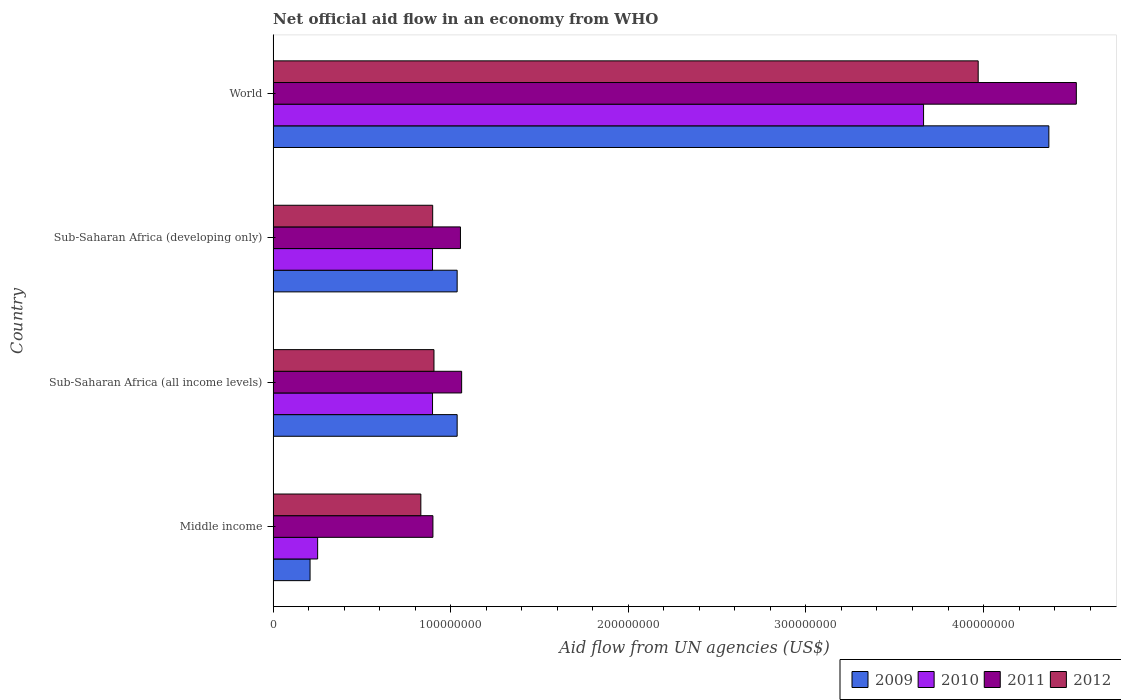How many groups of bars are there?
Your response must be concise. 4. Are the number of bars per tick equal to the number of legend labels?
Your answer should be very brief. Yes. Are the number of bars on each tick of the Y-axis equal?
Ensure brevity in your answer.  Yes. How many bars are there on the 1st tick from the bottom?
Your response must be concise. 4. In how many cases, is the number of bars for a given country not equal to the number of legend labels?
Provide a short and direct response. 0. What is the net official aid flow in 2010 in World?
Give a very brief answer. 3.66e+08. Across all countries, what is the maximum net official aid flow in 2010?
Keep it short and to the point. 3.66e+08. Across all countries, what is the minimum net official aid flow in 2009?
Provide a succinct answer. 2.08e+07. In which country was the net official aid flow in 2011 maximum?
Offer a very short reply. World. In which country was the net official aid flow in 2009 minimum?
Offer a terse response. Middle income. What is the total net official aid flow in 2012 in the graph?
Your answer should be very brief. 6.61e+08. What is the difference between the net official aid flow in 2011 in Middle income and that in World?
Your answer should be compact. -3.62e+08. What is the average net official aid flow in 2010 per country?
Your answer should be very brief. 1.43e+08. What is the difference between the net official aid flow in 2012 and net official aid flow in 2011 in Middle income?
Your response must be concise. -6.80e+06. What is the ratio of the net official aid flow in 2012 in Sub-Saharan Africa (all income levels) to that in World?
Keep it short and to the point. 0.23. Is the difference between the net official aid flow in 2012 in Middle income and World greater than the difference between the net official aid flow in 2011 in Middle income and World?
Provide a succinct answer. Yes. What is the difference between the highest and the second highest net official aid flow in 2010?
Keep it short and to the point. 2.76e+08. What is the difference between the highest and the lowest net official aid flow in 2009?
Your answer should be compact. 4.16e+08. In how many countries, is the net official aid flow in 2011 greater than the average net official aid flow in 2011 taken over all countries?
Your response must be concise. 1. Is it the case that in every country, the sum of the net official aid flow in 2010 and net official aid flow in 2011 is greater than the sum of net official aid flow in 2012 and net official aid flow in 2009?
Your answer should be compact. No. Is it the case that in every country, the sum of the net official aid flow in 2011 and net official aid flow in 2010 is greater than the net official aid flow in 2012?
Your answer should be very brief. Yes. What is the difference between two consecutive major ticks on the X-axis?
Your answer should be compact. 1.00e+08. Are the values on the major ticks of X-axis written in scientific E-notation?
Ensure brevity in your answer.  No. Does the graph contain grids?
Make the answer very short. No. Where does the legend appear in the graph?
Keep it short and to the point. Bottom right. How are the legend labels stacked?
Keep it short and to the point. Horizontal. What is the title of the graph?
Keep it short and to the point. Net official aid flow in an economy from WHO. Does "1994" appear as one of the legend labels in the graph?
Your answer should be very brief. No. What is the label or title of the X-axis?
Provide a short and direct response. Aid flow from UN agencies (US$). What is the Aid flow from UN agencies (US$) in 2009 in Middle income?
Your response must be concise. 2.08e+07. What is the Aid flow from UN agencies (US$) in 2010 in Middle income?
Keep it short and to the point. 2.51e+07. What is the Aid flow from UN agencies (US$) in 2011 in Middle income?
Give a very brief answer. 9.00e+07. What is the Aid flow from UN agencies (US$) of 2012 in Middle income?
Provide a short and direct response. 8.32e+07. What is the Aid flow from UN agencies (US$) in 2009 in Sub-Saharan Africa (all income levels)?
Ensure brevity in your answer.  1.04e+08. What is the Aid flow from UN agencies (US$) in 2010 in Sub-Saharan Africa (all income levels)?
Give a very brief answer. 8.98e+07. What is the Aid flow from UN agencies (US$) of 2011 in Sub-Saharan Africa (all income levels)?
Your answer should be compact. 1.06e+08. What is the Aid flow from UN agencies (US$) of 2012 in Sub-Saharan Africa (all income levels)?
Provide a succinct answer. 9.06e+07. What is the Aid flow from UN agencies (US$) in 2009 in Sub-Saharan Africa (developing only)?
Ensure brevity in your answer.  1.04e+08. What is the Aid flow from UN agencies (US$) of 2010 in Sub-Saharan Africa (developing only)?
Offer a terse response. 8.98e+07. What is the Aid flow from UN agencies (US$) of 2011 in Sub-Saharan Africa (developing only)?
Ensure brevity in your answer.  1.05e+08. What is the Aid flow from UN agencies (US$) of 2012 in Sub-Saharan Africa (developing only)?
Provide a succinct answer. 8.98e+07. What is the Aid flow from UN agencies (US$) in 2009 in World?
Ensure brevity in your answer.  4.37e+08. What is the Aid flow from UN agencies (US$) of 2010 in World?
Your response must be concise. 3.66e+08. What is the Aid flow from UN agencies (US$) in 2011 in World?
Make the answer very short. 4.52e+08. What is the Aid flow from UN agencies (US$) of 2012 in World?
Keep it short and to the point. 3.97e+08. Across all countries, what is the maximum Aid flow from UN agencies (US$) of 2009?
Your answer should be compact. 4.37e+08. Across all countries, what is the maximum Aid flow from UN agencies (US$) of 2010?
Offer a very short reply. 3.66e+08. Across all countries, what is the maximum Aid flow from UN agencies (US$) in 2011?
Ensure brevity in your answer.  4.52e+08. Across all countries, what is the maximum Aid flow from UN agencies (US$) in 2012?
Provide a succinct answer. 3.97e+08. Across all countries, what is the minimum Aid flow from UN agencies (US$) in 2009?
Offer a terse response. 2.08e+07. Across all countries, what is the minimum Aid flow from UN agencies (US$) in 2010?
Make the answer very short. 2.51e+07. Across all countries, what is the minimum Aid flow from UN agencies (US$) in 2011?
Offer a very short reply. 9.00e+07. Across all countries, what is the minimum Aid flow from UN agencies (US$) in 2012?
Provide a short and direct response. 8.32e+07. What is the total Aid flow from UN agencies (US$) of 2009 in the graph?
Ensure brevity in your answer.  6.65e+08. What is the total Aid flow from UN agencies (US$) of 2010 in the graph?
Ensure brevity in your answer.  5.71e+08. What is the total Aid flow from UN agencies (US$) of 2011 in the graph?
Your response must be concise. 7.54e+08. What is the total Aid flow from UN agencies (US$) of 2012 in the graph?
Your answer should be compact. 6.61e+08. What is the difference between the Aid flow from UN agencies (US$) of 2009 in Middle income and that in Sub-Saharan Africa (all income levels)?
Give a very brief answer. -8.28e+07. What is the difference between the Aid flow from UN agencies (US$) in 2010 in Middle income and that in Sub-Saharan Africa (all income levels)?
Give a very brief answer. -6.47e+07. What is the difference between the Aid flow from UN agencies (US$) in 2011 in Middle income and that in Sub-Saharan Africa (all income levels)?
Your answer should be compact. -1.62e+07. What is the difference between the Aid flow from UN agencies (US$) of 2012 in Middle income and that in Sub-Saharan Africa (all income levels)?
Offer a very short reply. -7.39e+06. What is the difference between the Aid flow from UN agencies (US$) of 2009 in Middle income and that in Sub-Saharan Africa (developing only)?
Your response must be concise. -8.28e+07. What is the difference between the Aid flow from UN agencies (US$) in 2010 in Middle income and that in Sub-Saharan Africa (developing only)?
Provide a short and direct response. -6.47e+07. What is the difference between the Aid flow from UN agencies (US$) of 2011 in Middle income and that in Sub-Saharan Africa (developing only)?
Provide a succinct answer. -1.55e+07. What is the difference between the Aid flow from UN agencies (US$) in 2012 in Middle income and that in Sub-Saharan Africa (developing only)?
Offer a very short reply. -6.67e+06. What is the difference between the Aid flow from UN agencies (US$) of 2009 in Middle income and that in World?
Make the answer very short. -4.16e+08. What is the difference between the Aid flow from UN agencies (US$) of 2010 in Middle income and that in World?
Ensure brevity in your answer.  -3.41e+08. What is the difference between the Aid flow from UN agencies (US$) in 2011 in Middle income and that in World?
Provide a succinct answer. -3.62e+08. What is the difference between the Aid flow from UN agencies (US$) in 2012 in Middle income and that in World?
Provide a succinct answer. -3.14e+08. What is the difference between the Aid flow from UN agencies (US$) in 2009 in Sub-Saharan Africa (all income levels) and that in Sub-Saharan Africa (developing only)?
Your answer should be very brief. 0. What is the difference between the Aid flow from UN agencies (US$) in 2010 in Sub-Saharan Africa (all income levels) and that in Sub-Saharan Africa (developing only)?
Make the answer very short. 0. What is the difference between the Aid flow from UN agencies (US$) in 2011 in Sub-Saharan Africa (all income levels) and that in Sub-Saharan Africa (developing only)?
Your answer should be compact. 6.70e+05. What is the difference between the Aid flow from UN agencies (US$) of 2012 in Sub-Saharan Africa (all income levels) and that in Sub-Saharan Africa (developing only)?
Provide a short and direct response. 7.20e+05. What is the difference between the Aid flow from UN agencies (US$) in 2009 in Sub-Saharan Africa (all income levels) and that in World?
Make the answer very short. -3.33e+08. What is the difference between the Aid flow from UN agencies (US$) in 2010 in Sub-Saharan Africa (all income levels) and that in World?
Provide a succinct answer. -2.76e+08. What is the difference between the Aid flow from UN agencies (US$) in 2011 in Sub-Saharan Africa (all income levels) and that in World?
Make the answer very short. -3.46e+08. What is the difference between the Aid flow from UN agencies (US$) of 2012 in Sub-Saharan Africa (all income levels) and that in World?
Give a very brief answer. -3.06e+08. What is the difference between the Aid flow from UN agencies (US$) in 2009 in Sub-Saharan Africa (developing only) and that in World?
Offer a terse response. -3.33e+08. What is the difference between the Aid flow from UN agencies (US$) of 2010 in Sub-Saharan Africa (developing only) and that in World?
Offer a terse response. -2.76e+08. What is the difference between the Aid flow from UN agencies (US$) in 2011 in Sub-Saharan Africa (developing only) and that in World?
Ensure brevity in your answer.  -3.47e+08. What is the difference between the Aid flow from UN agencies (US$) of 2012 in Sub-Saharan Africa (developing only) and that in World?
Offer a very short reply. -3.07e+08. What is the difference between the Aid flow from UN agencies (US$) of 2009 in Middle income and the Aid flow from UN agencies (US$) of 2010 in Sub-Saharan Africa (all income levels)?
Keep it short and to the point. -6.90e+07. What is the difference between the Aid flow from UN agencies (US$) of 2009 in Middle income and the Aid flow from UN agencies (US$) of 2011 in Sub-Saharan Africa (all income levels)?
Offer a very short reply. -8.54e+07. What is the difference between the Aid flow from UN agencies (US$) in 2009 in Middle income and the Aid flow from UN agencies (US$) in 2012 in Sub-Saharan Africa (all income levels)?
Offer a terse response. -6.98e+07. What is the difference between the Aid flow from UN agencies (US$) of 2010 in Middle income and the Aid flow from UN agencies (US$) of 2011 in Sub-Saharan Africa (all income levels)?
Keep it short and to the point. -8.11e+07. What is the difference between the Aid flow from UN agencies (US$) of 2010 in Middle income and the Aid flow from UN agencies (US$) of 2012 in Sub-Saharan Africa (all income levels)?
Keep it short and to the point. -6.55e+07. What is the difference between the Aid flow from UN agencies (US$) of 2011 in Middle income and the Aid flow from UN agencies (US$) of 2012 in Sub-Saharan Africa (all income levels)?
Ensure brevity in your answer.  -5.90e+05. What is the difference between the Aid flow from UN agencies (US$) in 2009 in Middle income and the Aid flow from UN agencies (US$) in 2010 in Sub-Saharan Africa (developing only)?
Ensure brevity in your answer.  -6.90e+07. What is the difference between the Aid flow from UN agencies (US$) of 2009 in Middle income and the Aid flow from UN agencies (US$) of 2011 in Sub-Saharan Africa (developing only)?
Give a very brief answer. -8.47e+07. What is the difference between the Aid flow from UN agencies (US$) in 2009 in Middle income and the Aid flow from UN agencies (US$) in 2012 in Sub-Saharan Africa (developing only)?
Ensure brevity in your answer.  -6.90e+07. What is the difference between the Aid flow from UN agencies (US$) of 2010 in Middle income and the Aid flow from UN agencies (US$) of 2011 in Sub-Saharan Africa (developing only)?
Ensure brevity in your answer.  -8.04e+07. What is the difference between the Aid flow from UN agencies (US$) of 2010 in Middle income and the Aid flow from UN agencies (US$) of 2012 in Sub-Saharan Africa (developing only)?
Keep it short and to the point. -6.48e+07. What is the difference between the Aid flow from UN agencies (US$) of 2009 in Middle income and the Aid flow from UN agencies (US$) of 2010 in World?
Your answer should be very brief. -3.45e+08. What is the difference between the Aid flow from UN agencies (US$) in 2009 in Middle income and the Aid flow from UN agencies (US$) in 2011 in World?
Offer a terse response. -4.31e+08. What is the difference between the Aid flow from UN agencies (US$) in 2009 in Middle income and the Aid flow from UN agencies (US$) in 2012 in World?
Ensure brevity in your answer.  -3.76e+08. What is the difference between the Aid flow from UN agencies (US$) of 2010 in Middle income and the Aid flow from UN agencies (US$) of 2011 in World?
Your response must be concise. -4.27e+08. What is the difference between the Aid flow from UN agencies (US$) in 2010 in Middle income and the Aid flow from UN agencies (US$) in 2012 in World?
Your answer should be very brief. -3.72e+08. What is the difference between the Aid flow from UN agencies (US$) of 2011 in Middle income and the Aid flow from UN agencies (US$) of 2012 in World?
Make the answer very short. -3.07e+08. What is the difference between the Aid flow from UN agencies (US$) of 2009 in Sub-Saharan Africa (all income levels) and the Aid flow from UN agencies (US$) of 2010 in Sub-Saharan Africa (developing only)?
Provide a succinct answer. 1.39e+07. What is the difference between the Aid flow from UN agencies (US$) of 2009 in Sub-Saharan Africa (all income levels) and the Aid flow from UN agencies (US$) of 2011 in Sub-Saharan Africa (developing only)?
Your response must be concise. -1.86e+06. What is the difference between the Aid flow from UN agencies (US$) of 2009 in Sub-Saharan Africa (all income levels) and the Aid flow from UN agencies (US$) of 2012 in Sub-Saharan Africa (developing only)?
Give a very brief answer. 1.38e+07. What is the difference between the Aid flow from UN agencies (US$) of 2010 in Sub-Saharan Africa (all income levels) and the Aid flow from UN agencies (US$) of 2011 in Sub-Saharan Africa (developing only)?
Your answer should be compact. -1.57e+07. What is the difference between the Aid flow from UN agencies (US$) of 2010 in Sub-Saharan Africa (all income levels) and the Aid flow from UN agencies (US$) of 2012 in Sub-Saharan Africa (developing only)?
Provide a succinct answer. -9.00e+04. What is the difference between the Aid flow from UN agencies (US$) in 2011 in Sub-Saharan Africa (all income levels) and the Aid flow from UN agencies (US$) in 2012 in Sub-Saharan Africa (developing only)?
Offer a terse response. 1.63e+07. What is the difference between the Aid flow from UN agencies (US$) in 2009 in Sub-Saharan Africa (all income levels) and the Aid flow from UN agencies (US$) in 2010 in World?
Offer a terse response. -2.63e+08. What is the difference between the Aid flow from UN agencies (US$) of 2009 in Sub-Saharan Africa (all income levels) and the Aid flow from UN agencies (US$) of 2011 in World?
Make the answer very short. -3.49e+08. What is the difference between the Aid flow from UN agencies (US$) of 2009 in Sub-Saharan Africa (all income levels) and the Aid flow from UN agencies (US$) of 2012 in World?
Offer a very short reply. -2.93e+08. What is the difference between the Aid flow from UN agencies (US$) of 2010 in Sub-Saharan Africa (all income levels) and the Aid flow from UN agencies (US$) of 2011 in World?
Keep it short and to the point. -3.62e+08. What is the difference between the Aid flow from UN agencies (US$) in 2010 in Sub-Saharan Africa (all income levels) and the Aid flow from UN agencies (US$) in 2012 in World?
Provide a succinct answer. -3.07e+08. What is the difference between the Aid flow from UN agencies (US$) in 2011 in Sub-Saharan Africa (all income levels) and the Aid flow from UN agencies (US$) in 2012 in World?
Give a very brief answer. -2.91e+08. What is the difference between the Aid flow from UN agencies (US$) of 2009 in Sub-Saharan Africa (developing only) and the Aid flow from UN agencies (US$) of 2010 in World?
Make the answer very short. -2.63e+08. What is the difference between the Aid flow from UN agencies (US$) of 2009 in Sub-Saharan Africa (developing only) and the Aid flow from UN agencies (US$) of 2011 in World?
Your answer should be compact. -3.49e+08. What is the difference between the Aid flow from UN agencies (US$) in 2009 in Sub-Saharan Africa (developing only) and the Aid flow from UN agencies (US$) in 2012 in World?
Give a very brief answer. -2.93e+08. What is the difference between the Aid flow from UN agencies (US$) of 2010 in Sub-Saharan Africa (developing only) and the Aid flow from UN agencies (US$) of 2011 in World?
Give a very brief answer. -3.62e+08. What is the difference between the Aid flow from UN agencies (US$) of 2010 in Sub-Saharan Africa (developing only) and the Aid flow from UN agencies (US$) of 2012 in World?
Offer a terse response. -3.07e+08. What is the difference between the Aid flow from UN agencies (US$) of 2011 in Sub-Saharan Africa (developing only) and the Aid flow from UN agencies (US$) of 2012 in World?
Provide a succinct answer. -2.92e+08. What is the average Aid flow from UN agencies (US$) of 2009 per country?
Keep it short and to the point. 1.66e+08. What is the average Aid flow from UN agencies (US$) of 2010 per country?
Your answer should be compact. 1.43e+08. What is the average Aid flow from UN agencies (US$) in 2011 per country?
Offer a terse response. 1.88e+08. What is the average Aid flow from UN agencies (US$) in 2012 per country?
Give a very brief answer. 1.65e+08. What is the difference between the Aid flow from UN agencies (US$) in 2009 and Aid flow from UN agencies (US$) in 2010 in Middle income?
Provide a short and direct response. -4.27e+06. What is the difference between the Aid flow from UN agencies (US$) in 2009 and Aid flow from UN agencies (US$) in 2011 in Middle income?
Provide a short and direct response. -6.92e+07. What is the difference between the Aid flow from UN agencies (US$) in 2009 and Aid flow from UN agencies (US$) in 2012 in Middle income?
Give a very brief answer. -6.24e+07. What is the difference between the Aid flow from UN agencies (US$) in 2010 and Aid flow from UN agencies (US$) in 2011 in Middle income?
Provide a succinct answer. -6.49e+07. What is the difference between the Aid flow from UN agencies (US$) in 2010 and Aid flow from UN agencies (US$) in 2012 in Middle income?
Your answer should be very brief. -5.81e+07. What is the difference between the Aid flow from UN agencies (US$) in 2011 and Aid flow from UN agencies (US$) in 2012 in Middle income?
Make the answer very short. 6.80e+06. What is the difference between the Aid flow from UN agencies (US$) of 2009 and Aid flow from UN agencies (US$) of 2010 in Sub-Saharan Africa (all income levels)?
Ensure brevity in your answer.  1.39e+07. What is the difference between the Aid flow from UN agencies (US$) in 2009 and Aid flow from UN agencies (US$) in 2011 in Sub-Saharan Africa (all income levels)?
Provide a succinct answer. -2.53e+06. What is the difference between the Aid flow from UN agencies (US$) in 2009 and Aid flow from UN agencies (US$) in 2012 in Sub-Saharan Africa (all income levels)?
Provide a short and direct response. 1.30e+07. What is the difference between the Aid flow from UN agencies (US$) of 2010 and Aid flow from UN agencies (US$) of 2011 in Sub-Saharan Africa (all income levels)?
Provide a succinct answer. -1.64e+07. What is the difference between the Aid flow from UN agencies (US$) in 2010 and Aid flow from UN agencies (US$) in 2012 in Sub-Saharan Africa (all income levels)?
Provide a succinct answer. -8.10e+05. What is the difference between the Aid flow from UN agencies (US$) in 2011 and Aid flow from UN agencies (US$) in 2012 in Sub-Saharan Africa (all income levels)?
Provide a short and direct response. 1.56e+07. What is the difference between the Aid flow from UN agencies (US$) of 2009 and Aid flow from UN agencies (US$) of 2010 in Sub-Saharan Africa (developing only)?
Your answer should be compact. 1.39e+07. What is the difference between the Aid flow from UN agencies (US$) of 2009 and Aid flow from UN agencies (US$) of 2011 in Sub-Saharan Africa (developing only)?
Offer a terse response. -1.86e+06. What is the difference between the Aid flow from UN agencies (US$) of 2009 and Aid flow from UN agencies (US$) of 2012 in Sub-Saharan Africa (developing only)?
Provide a short and direct response. 1.38e+07. What is the difference between the Aid flow from UN agencies (US$) of 2010 and Aid flow from UN agencies (US$) of 2011 in Sub-Saharan Africa (developing only)?
Provide a short and direct response. -1.57e+07. What is the difference between the Aid flow from UN agencies (US$) in 2010 and Aid flow from UN agencies (US$) in 2012 in Sub-Saharan Africa (developing only)?
Offer a terse response. -9.00e+04. What is the difference between the Aid flow from UN agencies (US$) in 2011 and Aid flow from UN agencies (US$) in 2012 in Sub-Saharan Africa (developing only)?
Offer a very short reply. 1.56e+07. What is the difference between the Aid flow from UN agencies (US$) of 2009 and Aid flow from UN agencies (US$) of 2010 in World?
Offer a very short reply. 7.06e+07. What is the difference between the Aid flow from UN agencies (US$) in 2009 and Aid flow from UN agencies (US$) in 2011 in World?
Make the answer very short. -1.55e+07. What is the difference between the Aid flow from UN agencies (US$) of 2009 and Aid flow from UN agencies (US$) of 2012 in World?
Provide a succinct answer. 3.98e+07. What is the difference between the Aid flow from UN agencies (US$) in 2010 and Aid flow from UN agencies (US$) in 2011 in World?
Provide a succinct answer. -8.60e+07. What is the difference between the Aid flow from UN agencies (US$) in 2010 and Aid flow from UN agencies (US$) in 2012 in World?
Your answer should be very brief. -3.08e+07. What is the difference between the Aid flow from UN agencies (US$) in 2011 and Aid flow from UN agencies (US$) in 2012 in World?
Keep it short and to the point. 5.53e+07. What is the ratio of the Aid flow from UN agencies (US$) of 2009 in Middle income to that in Sub-Saharan Africa (all income levels)?
Offer a very short reply. 0.2. What is the ratio of the Aid flow from UN agencies (US$) in 2010 in Middle income to that in Sub-Saharan Africa (all income levels)?
Offer a very short reply. 0.28. What is the ratio of the Aid flow from UN agencies (US$) in 2011 in Middle income to that in Sub-Saharan Africa (all income levels)?
Your response must be concise. 0.85. What is the ratio of the Aid flow from UN agencies (US$) in 2012 in Middle income to that in Sub-Saharan Africa (all income levels)?
Give a very brief answer. 0.92. What is the ratio of the Aid flow from UN agencies (US$) of 2009 in Middle income to that in Sub-Saharan Africa (developing only)?
Make the answer very short. 0.2. What is the ratio of the Aid flow from UN agencies (US$) in 2010 in Middle income to that in Sub-Saharan Africa (developing only)?
Keep it short and to the point. 0.28. What is the ratio of the Aid flow from UN agencies (US$) in 2011 in Middle income to that in Sub-Saharan Africa (developing only)?
Keep it short and to the point. 0.85. What is the ratio of the Aid flow from UN agencies (US$) in 2012 in Middle income to that in Sub-Saharan Africa (developing only)?
Provide a succinct answer. 0.93. What is the ratio of the Aid flow from UN agencies (US$) in 2009 in Middle income to that in World?
Your response must be concise. 0.05. What is the ratio of the Aid flow from UN agencies (US$) of 2010 in Middle income to that in World?
Provide a short and direct response. 0.07. What is the ratio of the Aid flow from UN agencies (US$) of 2011 in Middle income to that in World?
Make the answer very short. 0.2. What is the ratio of the Aid flow from UN agencies (US$) of 2012 in Middle income to that in World?
Your answer should be very brief. 0.21. What is the ratio of the Aid flow from UN agencies (US$) of 2011 in Sub-Saharan Africa (all income levels) to that in Sub-Saharan Africa (developing only)?
Your answer should be very brief. 1.01. What is the ratio of the Aid flow from UN agencies (US$) in 2009 in Sub-Saharan Africa (all income levels) to that in World?
Make the answer very short. 0.24. What is the ratio of the Aid flow from UN agencies (US$) of 2010 in Sub-Saharan Africa (all income levels) to that in World?
Offer a terse response. 0.25. What is the ratio of the Aid flow from UN agencies (US$) in 2011 in Sub-Saharan Africa (all income levels) to that in World?
Give a very brief answer. 0.23. What is the ratio of the Aid flow from UN agencies (US$) of 2012 in Sub-Saharan Africa (all income levels) to that in World?
Make the answer very short. 0.23. What is the ratio of the Aid flow from UN agencies (US$) of 2009 in Sub-Saharan Africa (developing only) to that in World?
Offer a very short reply. 0.24. What is the ratio of the Aid flow from UN agencies (US$) of 2010 in Sub-Saharan Africa (developing only) to that in World?
Your answer should be compact. 0.25. What is the ratio of the Aid flow from UN agencies (US$) in 2011 in Sub-Saharan Africa (developing only) to that in World?
Give a very brief answer. 0.23. What is the ratio of the Aid flow from UN agencies (US$) in 2012 in Sub-Saharan Africa (developing only) to that in World?
Provide a short and direct response. 0.23. What is the difference between the highest and the second highest Aid flow from UN agencies (US$) in 2009?
Your answer should be very brief. 3.33e+08. What is the difference between the highest and the second highest Aid flow from UN agencies (US$) of 2010?
Offer a very short reply. 2.76e+08. What is the difference between the highest and the second highest Aid flow from UN agencies (US$) of 2011?
Offer a terse response. 3.46e+08. What is the difference between the highest and the second highest Aid flow from UN agencies (US$) of 2012?
Give a very brief answer. 3.06e+08. What is the difference between the highest and the lowest Aid flow from UN agencies (US$) in 2009?
Make the answer very short. 4.16e+08. What is the difference between the highest and the lowest Aid flow from UN agencies (US$) of 2010?
Give a very brief answer. 3.41e+08. What is the difference between the highest and the lowest Aid flow from UN agencies (US$) in 2011?
Your answer should be compact. 3.62e+08. What is the difference between the highest and the lowest Aid flow from UN agencies (US$) of 2012?
Provide a short and direct response. 3.14e+08. 